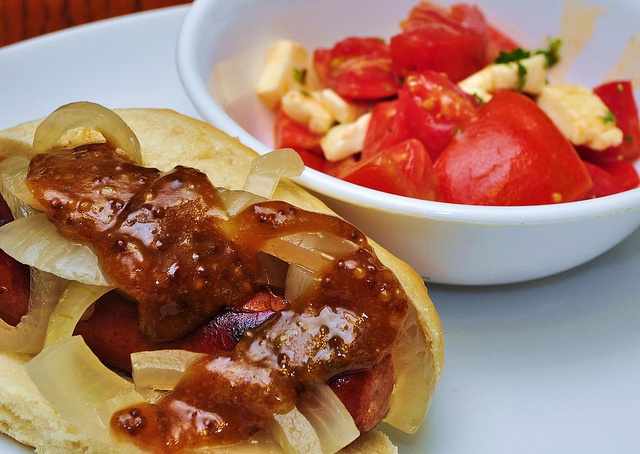Describe the objects in this image and their specific colors. I can see dining table in maroon, darkgray, brown, and lightgray tones and bowl in maroon, darkgray, brown, and tan tones in this image. 